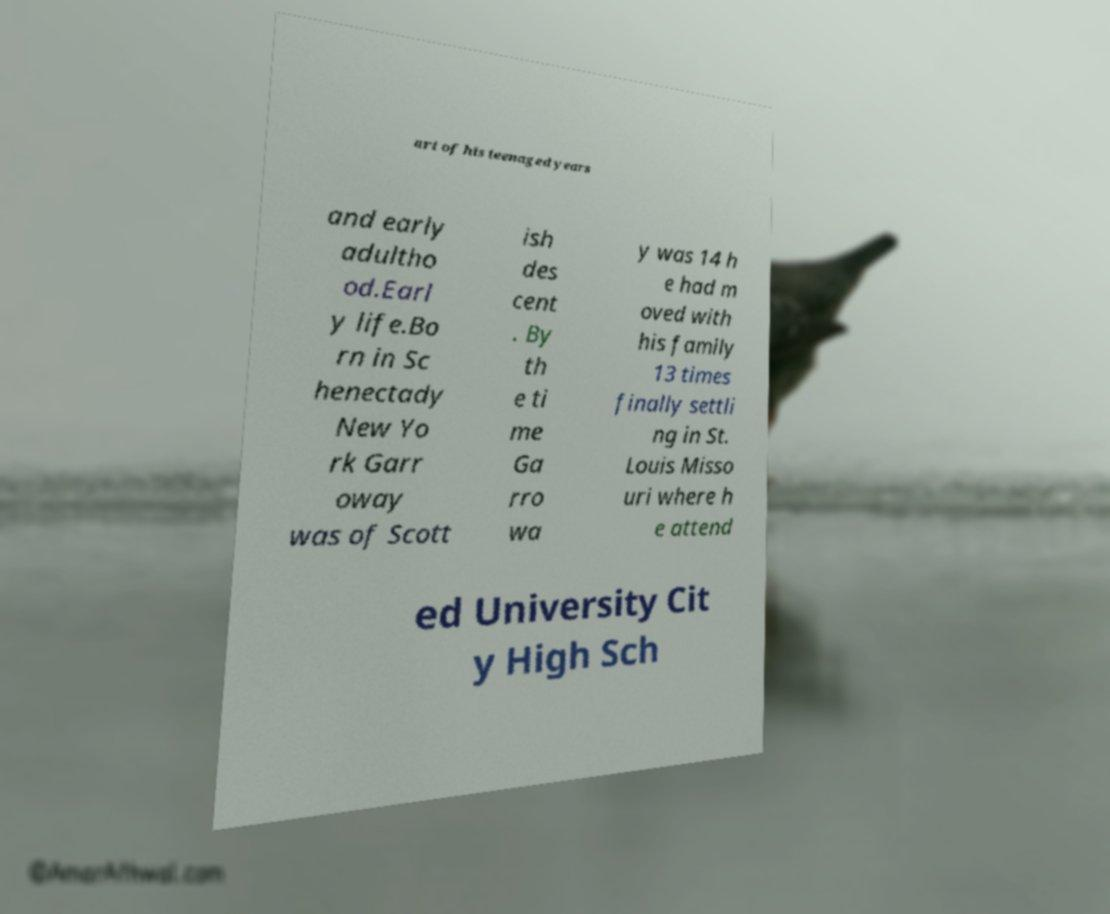Please identify and transcribe the text found in this image. art of his teenaged years and early adultho od.Earl y life.Bo rn in Sc henectady New Yo rk Garr oway was of Scott ish des cent . By th e ti me Ga rro wa y was 14 h e had m oved with his family 13 times finally settli ng in St. Louis Misso uri where h e attend ed University Cit y High Sch 